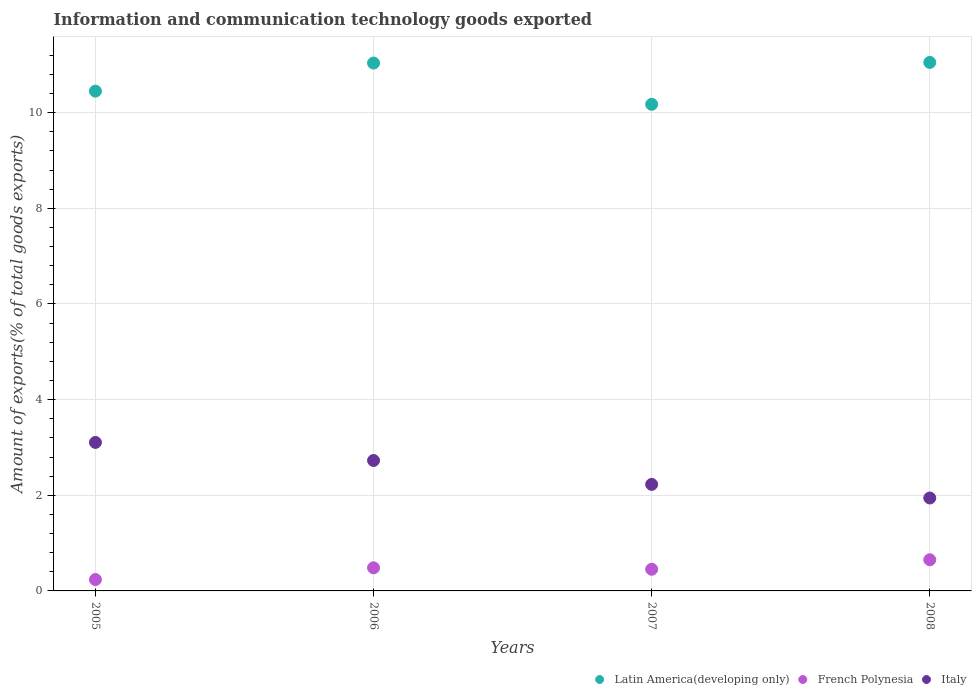Is the number of dotlines equal to the number of legend labels?
Offer a very short reply. Yes. What is the amount of goods exported in French Polynesia in 2008?
Your answer should be compact. 0.65. Across all years, what is the maximum amount of goods exported in Latin America(developing only)?
Ensure brevity in your answer.  11.05. Across all years, what is the minimum amount of goods exported in Latin America(developing only)?
Your response must be concise. 10.18. In which year was the amount of goods exported in Latin America(developing only) minimum?
Offer a very short reply. 2007. What is the total amount of goods exported in French Polynesia in the graph?
Offer a terse response. 1.83. What is the difference between the amount of goods exported in Latin America(developing only) in 2006 and that in 2007?
Your answer should be very brief. 0.86. What is the difference between the amount of goods exported in Latin America(developing only) in 2006 and the amount of goods exported in French Polynesia in 2007?
Give a very brief answer. 10.58. What is the average amount of goods exported in Latin America(developing only) per year?
Make the answer very short. 10.68. In the year 2006, what is the difference between the amount of goods exported in Latin America(developing only) and amount of goods exported in French Polynesia?
Offer a terse response. 10.55. What is the ratio of the amount of goods exported in Latin America(developing only) in 2006 to that in 2007?
Offer a terse response. 1.08. Is the amount of goods exported in French Polynesia in 2006 less than that in 2008?
Provide a succinct answer. Yes. Is the difference between the amount of goods exported in Latin America(developing only) in 2006 and 2008 greater than the difference between the amount of goods exported in French Polynesia in 2006 and 2008?
Offer a very short reply. Yes. What is the difference between the highest and the second highest amount of goods exported in Italy?
Provide a succinct answer. 0.38. What is the difference between the highest and the lowest amount of goods exported in Latin America(developing only)?
Your answer should be compact. 0.88. In how many years, is the amount of goods exported in Italy greater than the average amount of goods exported in Italy taken over all years?
Provide a short and direct response. 2. Is the amount of goods exported in Latin America(developing only) strictly greater than the amount of goods exported in Italy over the years?
Keep it short and to the point. Yes. Is the amount of goods exported in French Polynesia strictly less than the amount of goods exported in Italy over the years?
Your answer should be compact. Yes. How many years are there in the graph?
Your response must be concise. 4. How many legend labels are there?
Give a very brief answer. 3. What is the title of the graph?
Provide a succinct answer. Information and communication technology goods exported. Does "Jamaica" appear as one of the legend labels in the graph?
Ensure brevity in your answer.  No. What is the label or title of the X-axis?
Provide a succinct answer. Years. What is the label or title of the Y-axis?
Provide a short and direct response. Amount of exports(% of total goods exports). What is the Amount of exports(% of total goods exports) of Latin America(developing only) in 2005?
Your answer should be very brief. 10.45. What is the Amount of exports(% of total goods exports) in French Polynesia in 2005?
Offer a terse response. 0.24. What is the Amount of exports(% of total goods exports) of Italy in 2005?
Ensure brevity in your answer.  3.11. What is the Amount of exports(% of total goods exports) in Latin America(developing only) in 2006?
Ensure brevity in your answer.  11.04. What is the Amount of exports(% of total goods exports) of French Polynesia in 2006?
Ensure brevity in your answer.  0.48. What is the Amount of exports(% of total goods exports) of Italy in 2006?
Keep it short and to the point. 2.73. What is the Amount of exports(% of total goods exports) of Latin America(developing only) in 2007?
Ensure brevity in your answer.  10.18. What is the Amount of exports(% of total goods exports) in French Polynesia in 2007?
Provide a short and direct response. 0.45. What is the Amount of exports(% of total goods exports) in Italy in 2007?
Offer a very short reply. 2.23. What is the Amount of exports(% of total goods exports) of Latin America(developing only) in 2008?
Make the answer very short. 11.05. What is the Amount of exports(% of total goods exports) of French Polynesia in 2008?
Make the answer very short. 0.65. What is the Amount of exports(% of total goods exports) of Italy in 2008?
Offer a terse response. 1.94. Across all years, what is the maximum Amount of exports(% of total goods exports) of Latin America(developing only)?
Offer a terse response. 11.05. Across all years, what is the maximum Amount of exports(% of total goods exports) of French Polynesia?
Your answer should be very brief. 0.65. Across all years, what is the maximum Amount of exports(% of total goods exports) of Italy?
Give a very brief answer. 3.11. Across all years, what is the minimum Amount of exports(% of total goods exports) of Latin America(developing only)?
Give a very brief answer. 10.18. Across all years, what is the minimum Amount of exports(% of total goods exports) of French Polynesia?
Offer a terse response. 0.24. Across all years, what is the minimum Amount of exports(% of total goods exports) in Italy?
Your response must be concise. 1.94. What is the total Amount of exports(% of total goods exports) in Latin America(developing only) in the graph?
Ensure brevity in your answer.  42.71. What is the total Amount of exports(% of total goods exports) in French Polynesia in the graph?
Provide a short and direct response. 1.83. What is the total Amount of exports(% of total goods exports) of Italy in the graph?
Offer a very short reply. 10. What is the difference between the Amount of exports(% of total goods exports) in Latin America(developing only) in 2005 and that in 2006?
Your answer should be compact. -0.59. What is the difference between the Amount of exports(% of total goods exports) in French Polynesia in 2005 and that in 2006?
Offer a terse response. -0.25. What is the difference between the Amount of exports(% of total goods exports) of Italy in 2005 and that in 2006?
Offer a terse response. 0.38. What is the difference between the Amount of exports(% of total goods exports) in Latin America(developing only) in 2005 and that in 2007?
Ensure brevity in your answer.  0.28. What is the difference between the Amount of exports(% of total goods exports) in French Polynesia in 2005 and that in 2007?
Make the answer very short. -0.22. What is the difference between the Amount of exports(% of total goods exports) in Italy in 2005 and that in 2007?
Your answer should be compact. 0.88. What is the difference between the Amount of exports(% of total goods exports) of Latin America(developing only) in 2005 and that in 2008?
Give a very brief answer. -0.6. What is the difference between the Amount of exports(% of total goods exports) of French Polynesia in 2005 and that in 2008?
Your response must be concise. -0.41. What is the difference between the Amount of exports(% of total goods exports) in Italy in 2005 and that in 2008?
Offer a terse response. 1.16. What is the difference between the Amount of exports(% of total goods exports) of Latin America(developing only) in 2006 and that in 2007?
Ensure brevity in your answer.  0.86. What is the difference between the Amount of exports(% of total goods exports) in French Polynesia in 2006 and that in 2007?
Offer a terse response. 0.03. What is the difference between the Amount of exports(% of total goods exports) in Italy in 2006 and that in 2007?
Your answer should be very brief. 0.5. What is the difference between the Amount of exports(% of total goods exports) of Latin America(developing only) in 2006 and that in 2008?
Offer a terse response. -0.01. What is the difference between the Amount of exports(% of total goods exports) of French Polynesia in 2006 and that in 2008?
Provide a succinct answer. -0.17. What is the difference between the Amount of exports(% of total goods exports) of Italy in 2006 and that in 2008?
Provide a short and direct response. 0.78. What is the difference between the Amount of exports(% of total goods exports) in Latin America(developing only) in 2007 and that in 2008?
Give a very brief answer. -0.88. What is the difference between the Amount of exports(% of total goods exports) of French Polynesia in 2007 and that in 2008?
Keep it short and to the point. -0.2. What is the difference between the Amount of exports(% of total goods exports) of Italy in 2007 and that in 2008?
Ensure brevity in your answer.  0.28. What is the difference between the Amount of exports(% of total goods exports) of Latin America(developing only) in 2005 and the Amount of exports(% of total goods exports) of French Polynesia in 2006?
Provide a short and direct response. 9.97. What is the difference between the Amount of exports(% of total goods exports) in Latin America(developing only) in 2005 and the Amount of exports(% of total goods exports) in Italy in 2006?
Ensure brevity in your answer.  7.72. What is the difference between the Amount of exports(% of total goods exports) in French Polynesia in 2005 and the Amount of exports(% of total goods exports) in Italy in 2006?
Ensure brevity in your answer.  -2.49. What is the difference between the Amount of exports(% of total goods exports) in Latin America(developing only) in 2005 and the Amount of exports(% of total goods exports) in French Polynesia in 2007?
Keep it short and to the point. 10. What is the difference between the Amount of exports(% of total goods exports) in Latin America(developing only) in 2005 and the Amount of exports(% of total goods exports) in Italy in 2007?
Ensure brevity in your answer.  8.22. What is the difference between the Amount of exports(% of total goods exports) in French Polynesia in 2005 and the Amount of exports(% of total goods exports) in Italy in 2007?
Your answer should be compact. -1.99. What is the difference between the Amount of exports(% of total goods exports) of Latin America(developing only) in 2005 and the Amount of exports(% of total goods exports) of French Polynesia in 2008?
Your answer should be compact. 9.8. What is the difference between the Amount of exports(% of total goods exports) of Latin America(developing only) in 2005 and the Amount of exports(% of total goods exports) of Italy in 2008?
Provide a short and direct response. 8.51. What is the difference between the Amount of exports(% of total goods exports) in French Polynesia in 2005 and the Amount of exports(% of total goods exports) in Italy in 2008?
Keep it short and to the point. -1.71. What is the difference between the Amount of exports(% of total goods exports) of Latin America(developing only) in 2006 and the Amount of exports(% of total goods exports) of French Polynesia in 2007?
Give a very brief answer. 10.58. What is the difference between the Amount of exports(% of total goods exports) in Latin America(developing only) in 2006 and the Amount of exports(% of total goods exports) in Italy in 2007?
Keep it short and to the point. 8.81. What is the difference between the Amount of exports(% of total goods exports) in French Polynesia in 2006 and the Amount of exports(% of total goods exports) in Italy in 2007?
Provide a short and direct response. -1.74. What is the difference between the Amount of exports(% of total goods exports) of Latin America(developing only) in 2006 and the Amount of exports(% of total goods exports) of French Polynesia in 2008?
Offer a very short reply. 10.39. What is the difference between the Amount of exports(% of total goods exports) in Latin America(developing only) in 2006 and the Amount of exports(% of total goods exports) in Italy in 2008?
Provide a short and direct response. 9.09. What is the difference between the Amount of exports(% of total goods exports) of French Polynesia in 2006 and the Amount of exports(% of total goods exports) of Italy in 2008?
Make the answer very short. -1.46. What is the difference between the Amount of exports(% of total goods exports) in Latin America(developing only) in 2007 and the Amount of exports(% of total goods exports) in French Polynesia in 2008?
Offer a very short reply. 9.52. What is the difference between the Amount of exports(% of total goods exports) in Latin America(developing only) in 2007 and the Amount of exports(% of total goods exports) in Italy in 2008?
Provide a succinct answer. 8.23. What is the difference between the Amount of exports(% of total goods exports) in French Polynesia in 2007 and the Amount of exports(% of total goods exports) in Italy in 2008?
Your answer should be very brief. -1.49. What is the average Amount of exports(% of total goods exports) of Latin America(developing only) per year?
Your answer should be very brief. 10.68. What is the average Amount of exports(% of total goods exports) of French Polynesia per year?
Offer a very short reply. 0.46. What is the average Amount of exports(% of total goods exports) of Italy per year?
Provide a succinct answer. 2.5. In the year 2005, what is the difference between the Amount of exports(% of total goods exports) in Latin America(developing only) and Amount of exports(% of total goods exports) in French Polynesia?
Offer a very short reply. 10.21. In the year 2005, what is the difference between the Amount of exports(% of total goods exports) in Latin America(developing only) and Amount of exports(% of total goods exports) in Italy?
Your response must be concise. 7.35. In the year 2005, what is the difference between the Amount of exports(% of total goods exports) of French Polynesia and Amount of exports(% of total goods exports) of Italy?
Make the answer very short. -2.87. In the year 2006, what is the difference between the Amount of exports(% of total goods exports) in Latin America(developing only) and Amount of exports(% of total goods exports) in French Polynesia?
Offer a terse response. 10.55. In the year 2006, what is the difference between the Amount of exports(% of total goods exports) in Latin America(developing only) and Amount of exports(% of total goods exports) in Italy?
Offer a very short reply. 8.31. In the year 2006, what is the difference between the Amount of exports(% of total goods exports) in French Polynesia and Amount of exports(% of total goods exports) in Italy?
Your answer should be compact. -2.24. In the year 2007, what is the difference between the Amount of exports(% of total goods exports) in Latin America(developing only) and Amount of exports(% of total goods exports) in French Polynesia?
Ensure brevity in your answer.  9.72. In the year 2007, what is the difference between the Amount of exports(% of total goods exports) in Latin America(developing only) and Amount of exports(% of total goods exports) in Italy?
Make the answer very short. 7.95. In the year 2007, what is the difference between the Amount of exports(% of total goods exports) of French Polynesia and Amount of exports(% of total goods exports) of Italy?
Offer a very short reply. -1.77. In the year 2008, what is the difference between the Amount of exports(% of total goods exports) of Latin America(developing only) and Amount of exports(% of total goods exports) of French Polynesia?
Ensure brevity in your answer.  10.4. In the year 2008, what is the difference between the Amount of exports(% of total goods exports) in Latin America(developing only) and Amount of exports(% of total goods exports) in Italy?
Your answer should be compact. 9.11. In the year 2008, what is the difference between the Amount of exports(% of total goods exports) in French Polynesia and Amount of exports(% of total goods exports) in Italy?
Offer a terse response. -1.29. What is the ratio of the Amount of exports(% of total goods exports) of Latin America(developing only) in 2005 to that in 2006?
Keep it short and to the point. 0.95. What is the ratio of the Amount of exports(% of total goods exports) of French Polynesia in 2005 to that in 2006?
Your answer should be compact. 0.49. What is the ratio of the Amount of exports(% of total goods exports) of Italy in 2005 to that in 2006?
Provide a short and direct response. 1.14. What is the ratio of the Amount of exports(% of total goods exports) in French Polynesia in 2005 to that in 2007?
Provide a succinct answer. 0.52. What is the ratio of the Amount of exports(% of total goods exports) of Italy in 2005 to that in 2007?
Offer a terse response. 1.39. What is the ratio of the Amount of exports(% of total goods exports) in Latin America(developing only) in 2005 to that in 2008?
Make the answer very short. 0.95. What is the ratio of the Amount of exports(% of total goods exports) of French Polynesia in 2005 to that in 2008?
Your answer should be compact. 0.36. What is the ratio of the Amount of exports(% of total goods exports) in Italy in 2005 to that in 2008?
Your response must be concise. 1.6. What is the ratio of the Amount of exports(% of total goods exports) in Latin America(developing only) in 2006 to that in 2007?
Ensure brevity in your answer.  1.08. What is the ratio of the Amount of exports(% of total goods exports) in French Polynesia in 2006 to that in 2007?
Your answer should be compact. 1.07. What is the ratio of the Amount of exports(% of total goods exports) in Italy in 2006 to that in 2007?
Your answer should be compact. 1.22. What is the ratio of the Amount of exports(% of total goods exports) in Latin America(developing only) in 2006 to that in 2008?
Provide a short and direct response. 1. What is the ratio of the Amount of exports(% of total goods exports) in French Polynesia in 2006 to that in 2008?
Your answer should be compact. 0.74. What is the ratio of the Amount of exports(% of total goods exports) in Italy in 2006 to that in 2008?
Offer a terse response. 1.4. What is the ratio of the Amount of exports(% of total goods exports) in Latin America(developing only) in 2007 to that in 2008?
Provide a succinct answer. 0.92. What is the ratio of the Amount of exports(% of total goods exports) in French Polynesia in 2007 to that in 2008?
Your answer should be very brief. 0.69. What is the ratio of the Amount of exports(% of total goods exports) of Italy in 2007 to that in 2008?
Your response must be concise. 1.15. What is the difference between the highest and the second highest Amount of exports(% of total goods exports) in Latin America(developing only)?
Offer a very short reply. 0.01. What is the difference between the highest and the second highest Amount of exports(% of total goods exports) in French Polynesia?
Your response must be concise. 0.17. What is the difference between the highest and the second highest Amount of exports(% of total goods exports) of Italy?
Your answer should be compact. 0.38. What is the difference between the highest and the lowest Amount of exports(% of total goods exports) of Latin America(developing only)?
Give a very brief answer. 0.88. What is the difference between the highest and the lowest Amount of exports(% of total goods exports) in French Polynesia?
Your answer should be very brief. 0.41. What is the difference between the highest and the lowest Amount of exports(% of total goods exports) of Italy?
Provide a succinct answer. 1.16. 